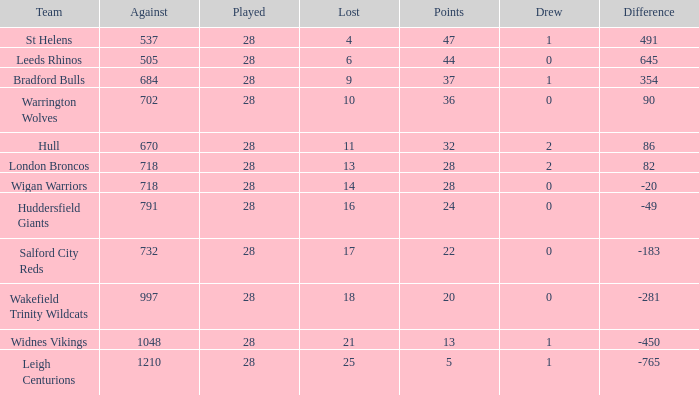What is the average points for a team that lost 4 and played more than 28 games? None. 